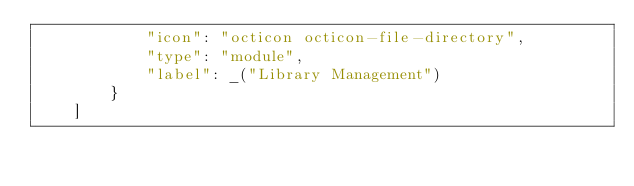Convert code to text. <code><loc_0><loc_0><loc_500><loc_500><_Python_>			"icon": "octicon octicon-file-directory",
			"type": "module",
			"label": _("Library Management")
		}
	]
</code> 